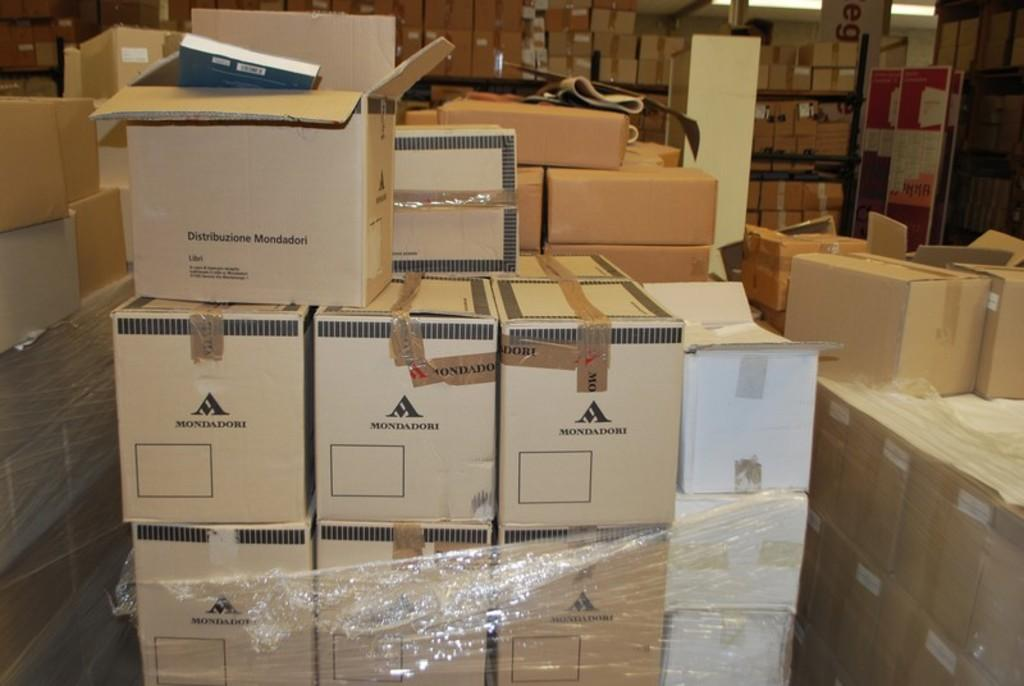<image>
Render a clear and concise summary of the photo. Mondadori boxes are packed and piled up in a storage room. 